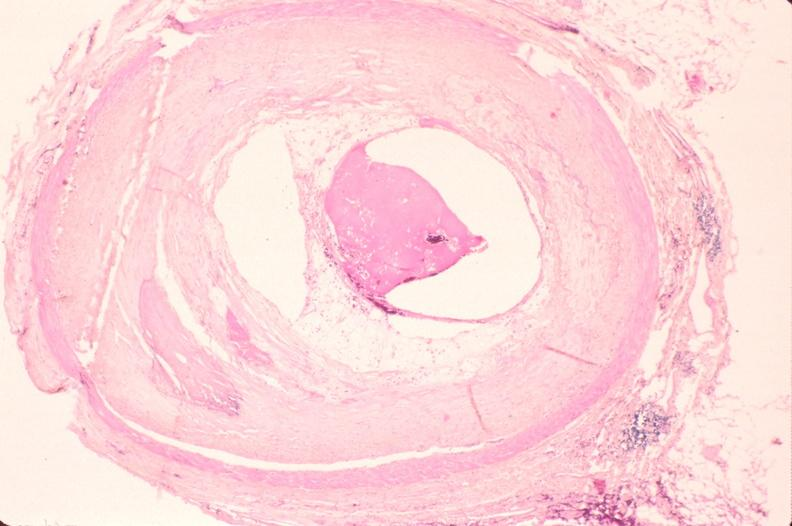s vasculature present?
Answer the question using a single word or phrase. Yes 